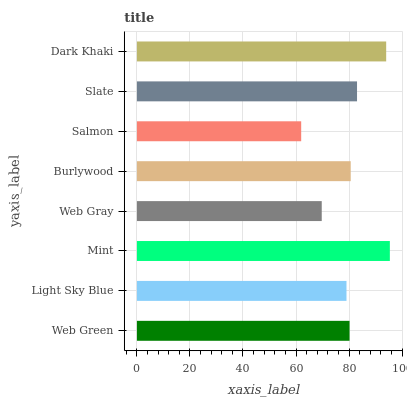Is Salmon the minimum?
Answer yes or no. Yes. Is Mint the maximum?
Answer yes or no. Yes. Is Light Sky Blue the minimum?
Answer yes or no. No. Is Light Sky Blue the maximum?
Answer yes or no. No. Is Web Green greater than Light Sky Blue?
Answer yes or no. Yes. Is Light Sky Blue less than Web Green?
Answer yes or no. Yes. Is Light Sky Blue greater than Web Green?
Answer yes or no. No. Is Web Green less than Light Sky Blue?
Answer yes or no. No. Is Burlywood the high median?
Answer yes or no. Yes. Is Web Green the low median?
Answer yes or no. Yes. Is Dark Khaki the high median?
Answer yes or no. No. Is Web Gray the low median?
Answer yes or no. No. 